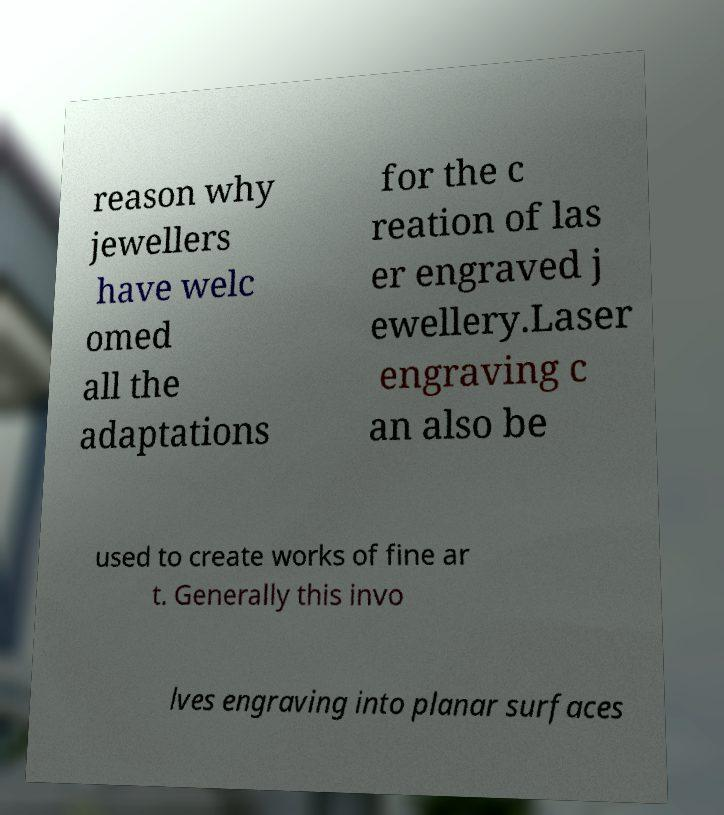There's text embedded in this image that I need extracted. Can you transcribe it verbatim? reason why jewellers have welc omed all the adaptations for the c reation of las er engraved j ewellery.Laser engraving c an also be used to create works of fine ar t. Generally this invo lves engraving into planar surfaces 